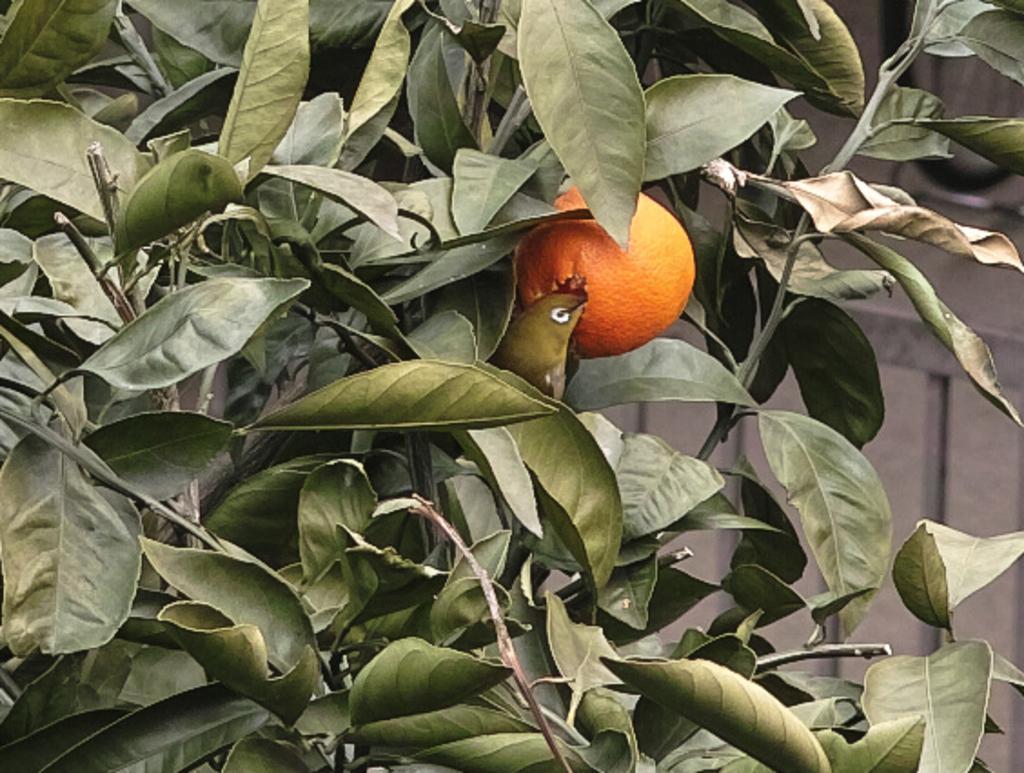Could you give a brief overview of what you see in this image? In this picture I can see a tree and a fruit and I can see a wall in the background. 